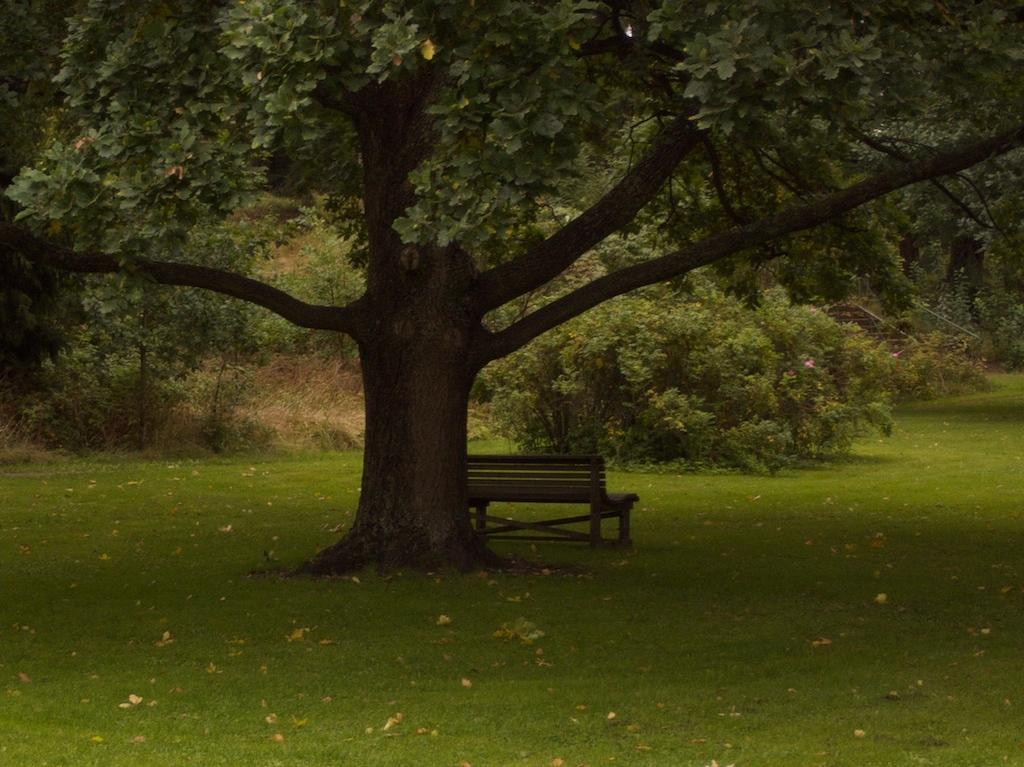What type of vegetation is present in the image? There is grass in the image. What type of seating is visible in the image? There is a bench in the image. What can be seen in the distance in the image? There are trees in the background of the image. What type of fruit is hanging from the trees in the image? There is no fruit visible in the image; only trees are present in the background. What trick is being performed on the bench in the image? There is no trick being performed in the image; the bench is simply a seating object. 